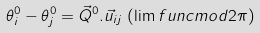Convert formula to latex. <formula><loc_0><loc_0><loc_500><loc_500>\theta _ { i } ^ { 0 } - \theta _ { j } ^ { 0 } = { \vec { Q } ^ { 0 } } . \vec { u } _ { i j } \, \left ( \lim f u n c { m o d } 2 \pi \right )</formula> 